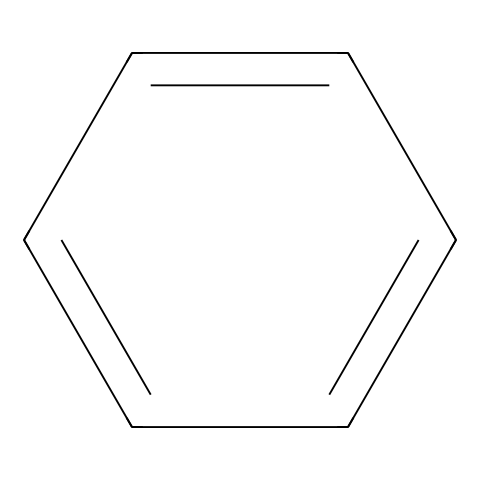What is the name of this chemical? The SMILES representation c1ccccc1 corresponds to benzene, which is a well-known aromatic hydrocarbon.
Answer: benzene How many carbon atoms are present in the structure? Analyzing the SMILES, we can see that the benzene ring consists of six carbon atoms.
Answer: 6 What type of bonding is predominantly present in this chemical? The structure shows alternating single and double bonds between carbon atoms, characteristic of resonance in benzene, indicating aromatic bonding.
Answer: aromatic What is the molecular formula of this compound? Based on the presence of 6 carbon atoms and 6 hydrogen atoms in the benzene ring, the molecular formula is C6H6.
Answer: C6H6 Why is benzene considered a hazardous chemical? Benzene is classified as hazardous due to its carcinogenic properties, as it poses health risks like leukemia upon prolonged exposure.
Answer: carcinogenic What is the physical state of benzene at room temperature? Benzene is a liquid at room temperature, usually observed as a clear and colorless liquid with a sweet odor.
Answer: liquid How does benzene's structure contribute to its volatility? The structure, with its low molecular weight and weak van der Waals forces between molecules, allows benzene to easily evaporate at room temperature, contributing to its volatility.
Answer: low volatility 